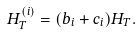<formula> <loc_0><loc_0><loc_500><loc_500>H ^ { ( i ) } _ { T } = ( b _ { i } + c _ { i } ) H _ { T } .</formula> 